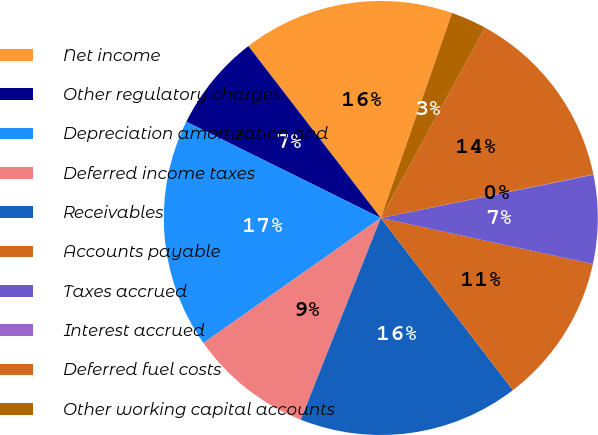Convert chart. <chart><loc_0><loc_0><loc_500><loc_500><pie_chart><fcel>Net income<fcel>Other regulatory charges<fcel>Depreciation amortization and<fcel>Deferred income taxes<fcel>Receivables<fcel>Accounts payable<fcel>Taxes accrued<fcel>Interest accrued<fcel>Deferred fuel costs<fcel>Other working capital accounts<nl><fcel>15.77%<fcel>7.24%<fcel>17.09%<fcel>9.21%<fcel>16.43%<fcel>11.18%<fcel>6.59%<fcel>0.03%<fcel>13.81%<fcel>2.65%<nl></chart> 